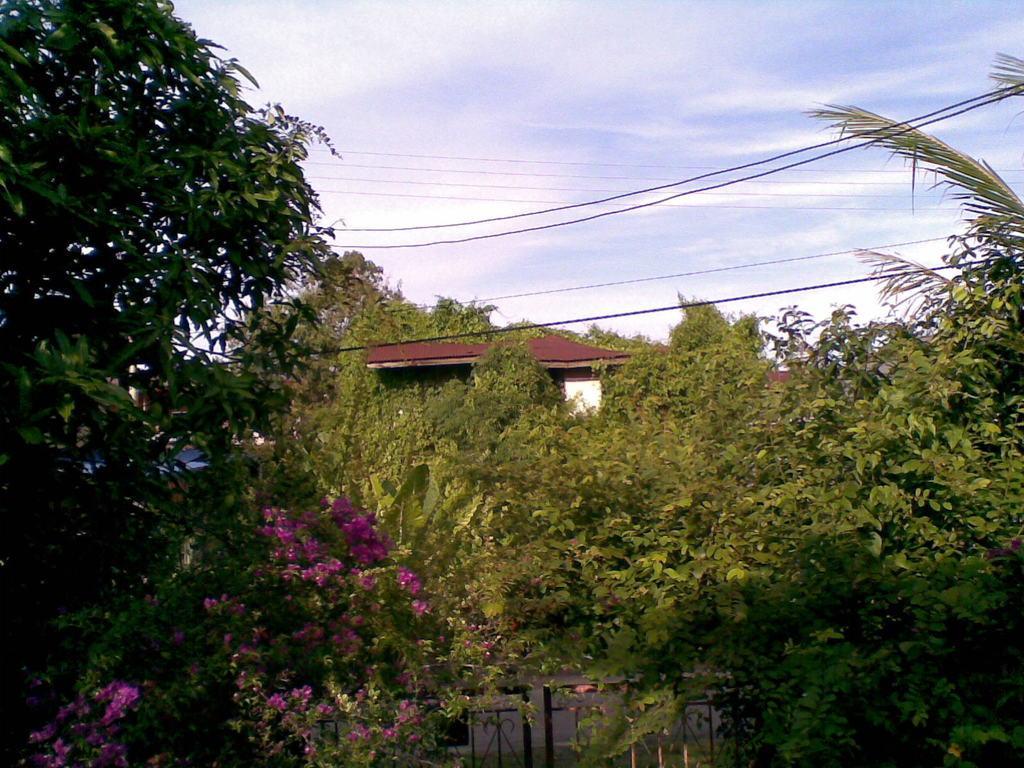In one or two sentences, can you explain what this image depicts? In this image I can see the pink color flowers to the plants. In-between these plants and trees I can see the house. In the background I can see the clouds and the sky. 